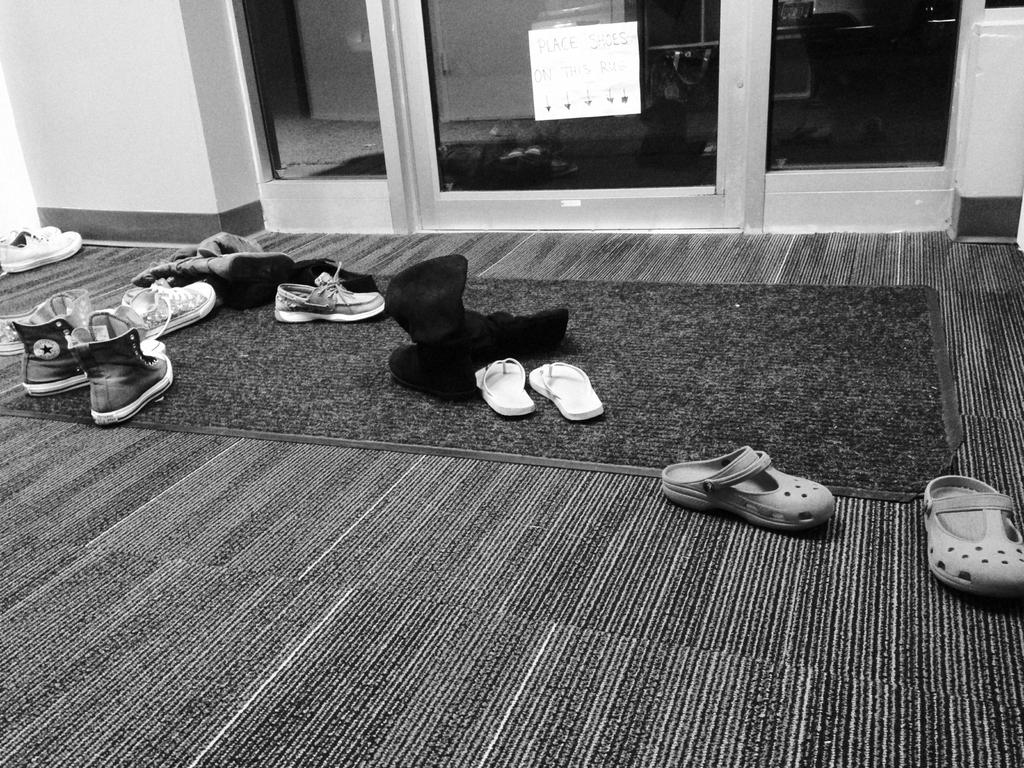What is the color scheme of the image? The image is black and white. What can be seen on the carpet in the image? There are pairs of footwear on the carpet. What is present in the background of the image? There is a paper attached to a glass object in the background. What type of lace is used to decorate the footwear in the image? There is no lace present on the footwear in the image, as it is a black and white image and the details of the footwear are not visible. 